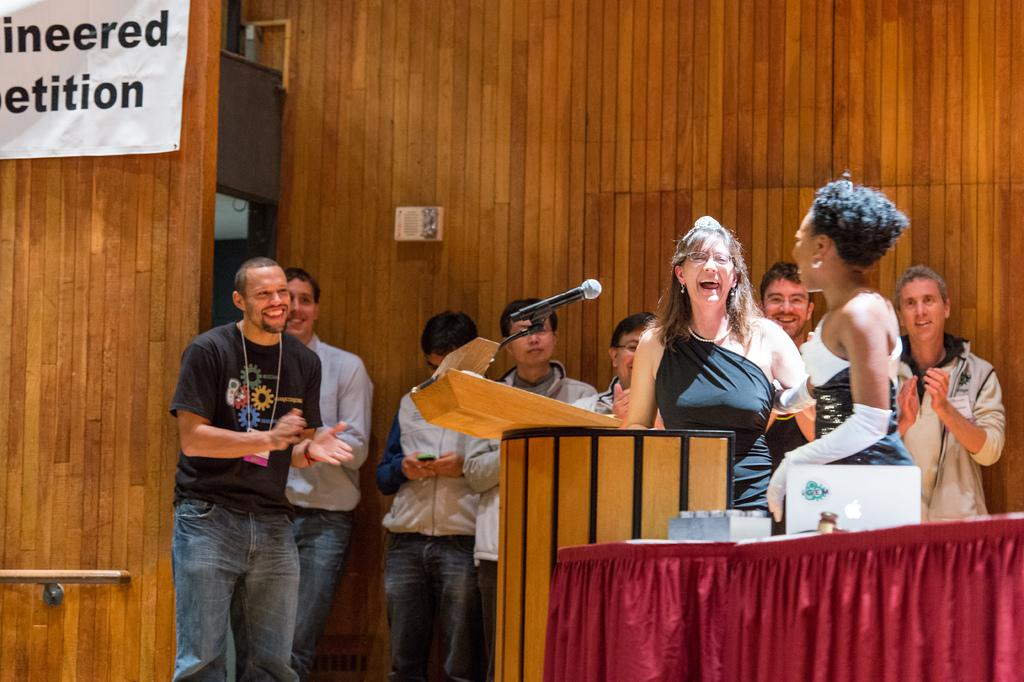How many people are in the image? There is a group of people in the image, but the exact number is not specified. What object is present for amplifying sound in the image? There is a microphone (mike) in the image. What is the person at the front of the group likely using? The person at the front of the group is likely using a podium, which can be seen in the image. What is the purpose of the table in the image? The table in the image might be used for holding notes, documents, or other items related to the event. What type of material is draped over the podium? There is a cloth in the image, which is draped over the podium. What can be seen in the background of the image? In the background of the image, there is a wall and a banner. Can you describe the ocean waves in the image? There is no ocean or waves present in the image. How does the rainstorm affect the event in the image? There is no rainstorm depicted in the image. 